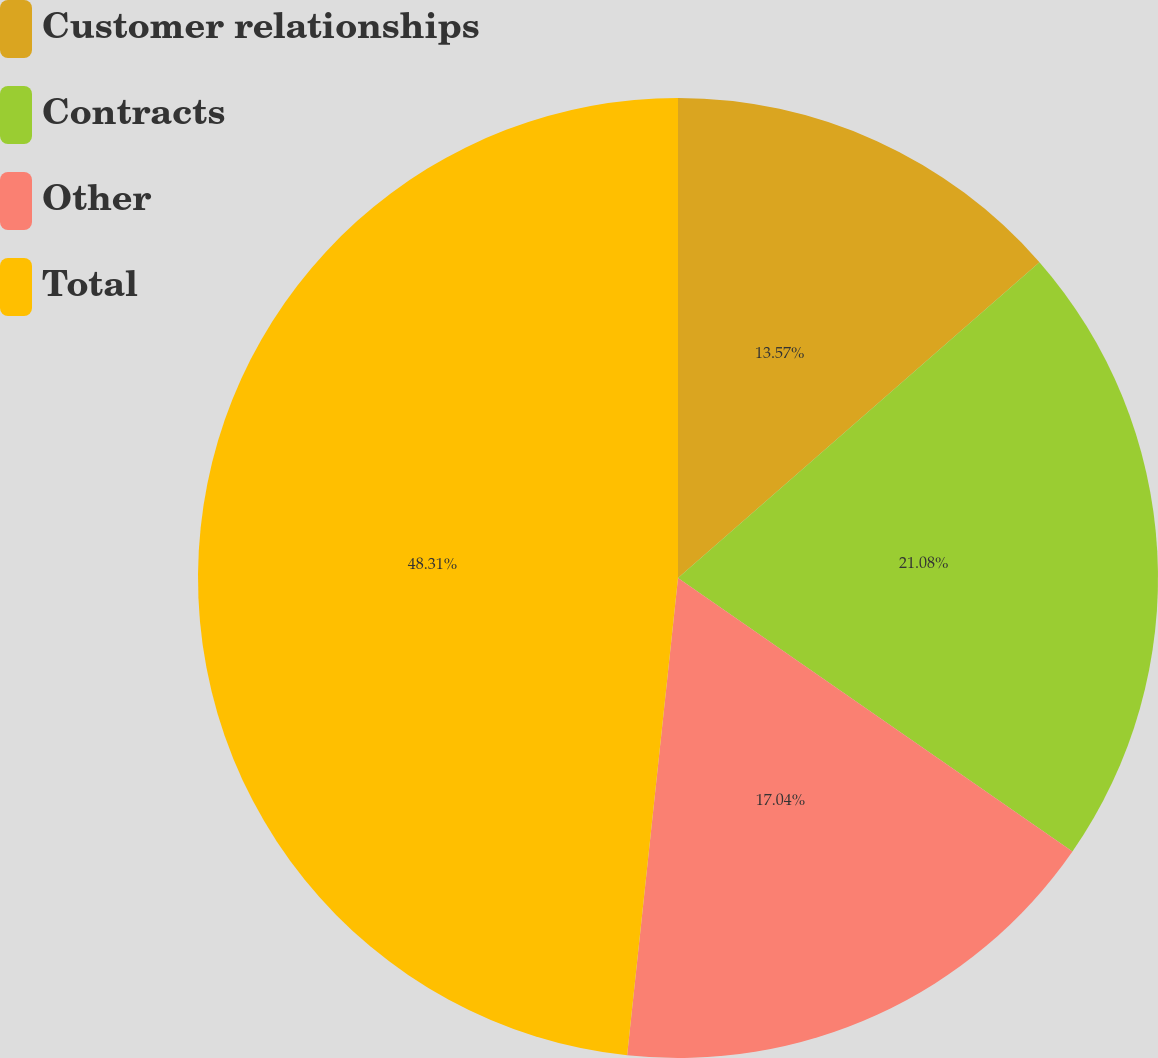Convert chart to OTSL. <chart><loc_0><loc_0><loc_500><loc_500><pie_chart><fcel>Customer relationships<fcel>Contracts<fcel>Other<fcel>Total<nl><fcel>13.57%<fcel>21.08%<fcel>17.04%<fcel>48.31%<nl></chart> 